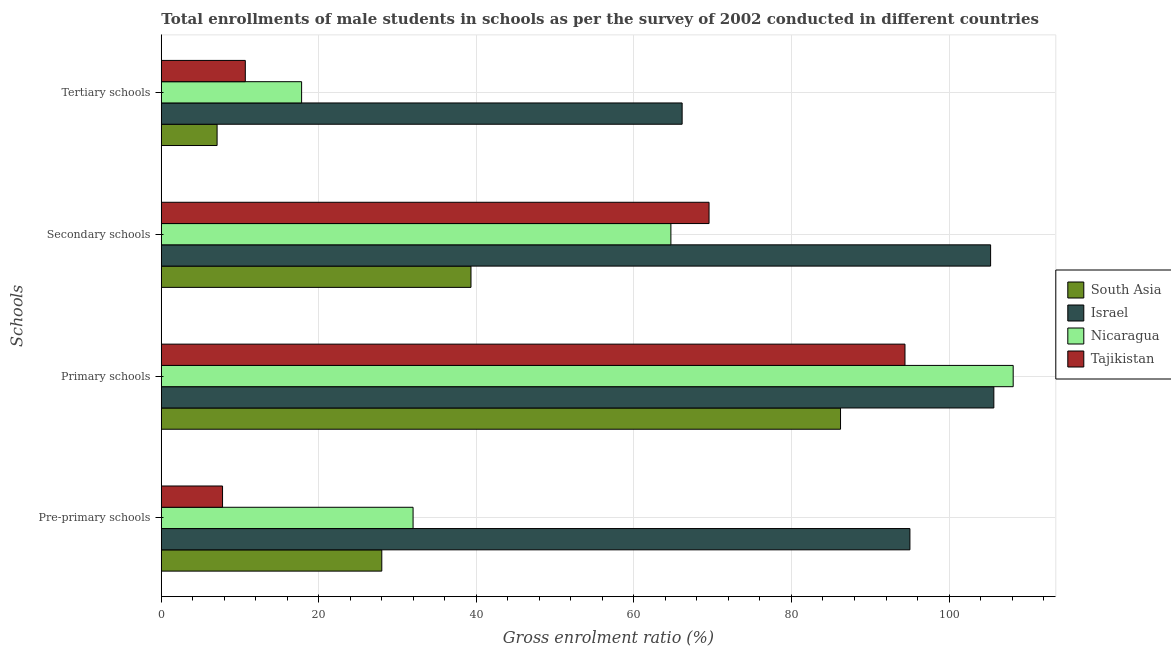How many bars are there on the 4th tick from the top?
Provide a succinct answer. 4. What is the label of the 2nd group of bars from the top?
Keep it short and to the point. Secondary schools. What is the gross enrolment ratio(male) in pre-primary schools in Israel?
Offer a terse response. 95.04. Across all countries, what is the maximum gross enrolment ratio(male) in primary schools?
Your response must be concise. 108.15. Across all countries, what is the minimum gross enrolment ratio(male) in pre-primary schools?
Your answer should be very brief. 7.77. What is the total gross enrolment ratio(male) in secondary schools in the graph?
Provide a succinct answer. 278.82. What is the difference between the gross enrolment ratio(male) in primary schools in South Asia and that in Israel?
Keep it short and to the point. -19.46. What is the difference between the gross enrolment ratio(male) in tertiary schools in Tajikistan and the gross enrolment ratio(male) in primary schools in Israel?
Offer a terse response. -95.03. What is the average gross enrolment ratio(male) in tertiary schools per country?
Make the answer very short. 25.42. What is the difference between the gross enrolment ratio(male) in primary schools and gross enrolment ratio(male) in secondary schools in Nicaragua?
Offer a very short reply. 43.46. In how many countries, is the gross enrolment ratio(male) in tertiary schools greater than 40 %?
Your answer should be compact. 1. What is the ratio of the gross enrolment ratio(male) in secondary schools in Tajikistan to that in South Asia?
Provide a short and direct response. 1.77. Is the difference between the gross enrolment ratio(male) in primary schools in Nicaragua and Israel greater than the difference between the gross enrolment ratio(male) in pre-primary schools in Nicaragua and Israel?
Provide a succinct answer. Yes. What is the difference between the highest and the second highest gross enrolment ratio(male) in primary schools?
Your answer should be very brief. 2.46. What is the difference between the highest and the lowest gross enrolment ratio(male) in primary schools?
Your response must be concise. 21.92. Is it the case that in every country, the sum of the gross enrolment ratio(male) in primary schools and gross enrolment ratio(male) in tertiary schools is greater than the sum of gross enrolment ratio(male) in pre-primary schools and gross enrolment ratio(male) in secondary schools?
Ensure brevity in your answer.  No. What does the 4th bar from the top in Pre-primary schools represents?
Give a very brief answer. South Asia. What does the 4th bar from the bottom in Secondary schools represents?
Keep it short and to the point. Tajikistan. Are all the bars in the graph horizontal?
Provide a succinct answer. Yes. How many countries are there in the graph?
Give a very brief answer. 4. What is the difference between two consecutive major ticks on the X-axis?
Ensure brevity in your answer.  20. Are the values on the major ticks of X-axis written in scientific E-notation?
Ensure brevity in your answer.  No. Does the graph contain any zero values?
Keep it short and to the point. No. Does the graph contain grids?
Your answer should be very brief. Yes. Where does the legend appear in the graph?
Provide a short and direct response. Center right. What is the title of the graph?
Ensure brevity in your answer.  Total enrollments of male students in schools as per the survey of 2002 conducted in different countries. What is the label or title of the Y-axis?
Provide a succinct answer. Schools. What is the Gross enrolment ratio (%) of South Asia in Pre-primary schools?
Your answer should be compact. 27.99. What is the Gross enrolment ratio (%) in Israel in Pre-primary schools?
Provide a succinct answer. 95.04. What is the Gross enrolment ratio (%) in Nicaragua in Pre-primary schools?
Offer a very short reply. 31.96. What is the Gross enrolment ratio (%) in Tajikistan in Pre-primary schools?
Give a very brief answer. 7.77. What is the Gross enrolment ratio (%) in South Asia in Primary schools?
Make the answer very short. 86.23. What is the Gross enrolment ratio (%) in Israel in Primary schools?
Keep it short and to the point. 105.69. What is the Gross enrolment ratio (%) in Nicaragua in Primary schools?
Provide a succinct answer. 108.15. What is the Gross enrolment ratio (%) of Tajikistan in Primary schools?
Your answer should be compact. 94.41. What is the Gross enrolment ratio (%) of South Asia in Secondary schools?
Give a very brief answer. 39.31. What is the Gross enrolment ratio (%) of Israel in Secondary schools?
Give a very brief answer. 105.28. What is the Gross enrolment ratio (%) of Nicaragua in Secondary schools?
Provide a short and direct response. 64.69. What is the Gross enrolment ratio (%) of Tajikistan in Secondary schools?
Provide a short and direct response. 69.54. What is the Gross enrolment ratio (%) in South Asia in Tertiary schools?
Make the answer very short. 7.08. What is the Gross enrolment ratio (%) of Israel in Tertiary schools?
Offer a very short reply. 66.12. What is the Gross enrolment ratio (%) in Nicaragua in Tertiary schools?
Give a very brief answer. 17.81. What is the Gross enrolment ratio (%) in Tajikistan in Tertiary schools?
Your response must be concise. 10.66. Across all Schools, what is the maximum Gross enrolment ratio (%) of South Asia?
Your answer should be compact. 86.23. Across all Schools, what is the maximum Gross enrolment ratio (%) of Israel?
Offer a very short reply. 105.69. Across all Schools, what is the maximum Gross enrolment ratio (%) of Nicaragua?
Offer a terse response. 108.15. Across all Schools, what is the maximum Gross enrolment ratio (%) in Tajikistan?
Provide a short and direct response. 94.41. Across all Schools, what is the minimum Gross enrolment ratio (%) of South Asia?
Offer a terse response. 7.08. Across all Schools, what is the minimum Gross enrolment ratio (%) of Israel?
Your answer should be compact. 66.12. Across all Schools, what is the minimum Gross enrolment ratio (%) in Nicaragua?
Offer a very short reply. 17.81. Across all Schools, what is the minimum Gross enrolment ratio (%) of Tajikistan?
Make the answer very short. 7.77. What is the total Gross enrolment ratio (%) in South Asia in the graph?
Offer a terse response. 160.61. What is the total Gross enrolment ratio (%) in Israel in the graph?
Offer a terse response. 372.13. What is the total Gross enrolment ratio (%) in Nicaragua in the graph?
Your answer should be very brief. 222.61. What is the total Gross enrolment ratio (%) of Tajikistan in the graph?
Provide a succinct answer. 182.38. What is the difference between the Gross enrolment ratio (%) in South Asia in Pre-primary schools and that in Primary schools?
Provide a short and direct response. -58.24. What is the difference between the Gross enrolment ratio (%) in Israel in Pre-primary schools and that in Primary schools?
Provide a short and direct response. -10.65. What is the difference between the Gross enrolment ratio (%) of Nicaragua in Pre-primary schools and that in Primary schools?
Ensure brevity in your answer.  -76.19. What is the difference between the Gross enrolment ratio (%) in Tajikistan in Pre-primary schools and that in Primary schools?
Your response must be concise. -86.64. What is the difference between the Gross enrolment ratio (%) in South Asia in Pre-primary schools and that in Secondary schools?
Give a very brief answer. -11.32. What is the difference between the Gross enrolment ratio (%) of Israel in Pre-primary schools and that in Secondary schools?
Provide a succinct answer. -10.24. What is the difference between the Gross enrolment ratio (%) of Nicaragua in Pre-primary schools and that in Secondary schools?
Offer a very short reply. -32.73. What is the difference between the Gross enrolment ratio (%) in Tajikistan in Pre-primary schools and that in Secondary schools?
Your answer should be compact. -61.76. What is the difference between the Gross enrolment ratio (%) of South Asia in Pre-primary schools and that in Tertiary schools?
Make the answer very short. 20.91. What is the difference between the Gross enrolment ratio (%) in Israel in Pre-primary schools and that in Tertiary schools?
Your answer should be compact. 28.92. What is the difference between the Gross enrolment ratio (%) in Nicaragua in Pre-primary schools and that in Tertiary schools?
Your answer should be compact. 14.15. What is the difference between the Gross enrolment ratio (%) in Tajikistan in Pre-primary schools and that in Tertiary schools?
Your answer should be compact. -2.89. What is the difference between the Gross enrolment ratio (%) in South Asia in Primary schools and that in Secondary schools?
Provide a succinct answer. 46.91. What is the difference between the Gross enrolment ratio (%) of Israel in Primary schools and that in Secondary schools?
Your response must be concise. 0.41. What is the difference between the Gross enrolment ratio (%) in Nicaragua in Primary schools and that in Secondary schools?
Offer a very short reply. 43.46. What is the difference between the Gross enrolment ratio (%) in Tajikistan in Primary schools and that in Secondary schools?
Your response must be concise. 24.87. What is the difference between the Gross enrolment ratio (%) of South Asia in Primary schools and that in Tertiary schools?
Your answer should be very brief. 79.15. What is the difference between the Gross enrolment ratio (%) in Israel in Primary schools and that in Tertiary schools?
Offer a terse response. 39.57. What is the difference between the Gross enrolment ratio (%) of Nicaragua in Primary schools and that in Tertiary schools?
Your response must be concise. 90.34. What is the difference between the Gross enrolment ratio (%) in Tajikistan in Primary schools and that in Tertiary schools?
Keep it short and to the point. 83.75. What is the difference between the Gross enrolment ratio (%) in South Asia in Secondary schools and that in Tertiary schools?
Give a very brief answer. 32.23. What is the difference between the Gross enrolment ratio (%) in Israel in Secondary schools and that in Tertiary schools?
Give a very brief answer. 39.16. What is the difference between the Gross enrolment ratio (%) of Nicaragua in Secondary schools and that in Tertiary schools?
Ensure brevity in your answer.  46.88. What is the difference between the Gross enrolment ratio (%) in Tajikistan in Secondary schools and that in Tertiary schools?
Provide a succinct answer. 58.87. What is the difference between the Gross enrolment ratio (%) in South Asia in Pre-primary schools and the Gross enrolment ratio (%) in Israel in Primary schools?
Give a very brief answer. -77.7. What is the difference between the Gross enrolment ratio (%) of South Asia in Pre-primary schools and the Gross enrolment ratio (%) of Nicaragua in Primary schools?
Offer a very short reply. -80.16. What is the difference between the Gross enrolment ratio (%) in South Asia in Pre-primary schools and the Gross enrolment ratio (%) in Tajikistan in Primary schools?
Ensure brevity in your answer.  -66.42. What is the difference between the Gross enrolment ratio (%) of Israel in Pre-primary schools and the Gross enrolment ratio (%) of Nicaragua in Primary schools?
Offer a terse response. -13.11. What is the difference between the Gross enrolment ratio (%) in Israel in Pre-primary schools and the Gross enrolment ratio (%) in Tajikistan in Primary schools?
Your response must be concise. 0.63. What is the difference between the Gross enrolment ratio (%) in Nicaragua in Pre-primary schools and the Gross enrolment ratio (%) in Tajikistan in Primary schools?
Your answer should be compact. -62.45. What is the difference between the Gross enrolment ratio (%) of South Asia in Pre-primary schools and the Gross enrolment ratio (%) of Israel in Secondary schools?
Provide a short and direct response. -77.29. What is the difference between the Gross enrolment ratio (%) in South Asia in Pre-primary schools and the Gross enrolment ratio (%) in Nicaragua in Secondary schools?
Provide a short and direct response. -36.7. What is the difference between the Gross enrolment ratio (%) in South Asia in Pre-primary schools and the Gross enrolment ratio (%) in Tajikistan in Secondary schools?
Provide a short and direct response. -41.55. What is the difference between the Gross enrolment ratio (%) in Israel in Pre-primary schools and the Gross enrolment ratio (%) in Nicaragua in Secondary schools?
Provide a short and direct response. 30.35. What is the difference between the Gross enrolment ratio (%) of Israel in Pre-primary schools and the Gross enrolment ratio (%) of Tajikistan in Secondary schools?
Give a very brief answer. 25.5. What is the difference between the Gross enrolment ratio (%) of Nicaragua in Pre-primary schools and the Gross enrolment ratio (%) of Tajikistan in Secondary schools?
Make the answer very short. -37.57. What is the difference between the Gross enrolment ratio (%) of South Asia in Pre-primary schools and the Gross enrolment ratio (%) of Israel in Tertiary schools?
Provide a succinct answer. -38.13. What is the difference between the Gross enrolment ratio (%) of South Asia in Pre-primary schools and the Gross enrolment ratio (%) of Nicaragua in Tertiary schools?
Offer a very short reply. 10.18. What is the difference between the Gross enrolment ratio (%) in South Asia in Pre-primary schools and the Gross enrolment ratio (%) in Tajikistan in Tertiary schools?
Offer a terse response. 17.33. What is the difference between the Gross enrolment ratio (%) in Israel in Pre-primary schools and the Gross enrolment ratio (%) in Nicaragua in Tertiary schools?
Provide a short and direct response. 77.23. What is the difference between the Gross enrolment ratio (%) in Israel in Pre-primary schools and the Gross enrolment ratio (%) in Tajikistan in Tertiary schools?
Give a very brief answer. 84.37. What is the difference between the Gross enrolment ratio (%) of Nicaragua in Pre-primary schools and the Gross enrolment ratio (%) of Tajikistan in Tertiary schools?
Provide a short and direct response. 21.3. What is the difference between the Gross enrolment ratio (%) in South Asia in Primary schools and the Gross enrolment ratio (%) in Israel in Secondary schools?
Provide a short and direct response. -19.05. What is the difference between the Gross enrolment ratio (%) of South Asia in Primary schools and the Gross enrolment ratio (%) of Nicaragua in Secondary schools?
Offer a terse response. 21.53. What is the difference between the Gross enrolment ratio (%) of South Asia in Primary schools and the Gross enrolment ratio (%) of Tajikistan in Secondary schools?
Give a very brief answer. 16.69. What is the difference between the Gross enrolment ratio (%) of Israel in Primary schools and the Gross enrolment ratio (%) of Nicaragua in Secondary schools?
Your answer should be very brief. 41. What is the difference between the Gross enrolment ratio (%) in Israel in Primary schools and the Gross enrolment ratio (%) in Tajikistan in Secondary schools?
Ensure brevity in your answer.  36.15. What is the difference between the Gross enrolment ratio (%) in Nicaragua in Primary schools and the Gross enrolment ratio (%) in Tajikistan in Secondary schools?
Give a very brief answer. 38.61. What is the difference between the Gross enrolment ratio (%) in South Asia in Primary schools and the Gross enrolment ratio (%) in Israel in Tertiary schools?
Your answer should be compact. 20.11. What is the difference between the Gross enrolment ratio (%) in South Asia in Primary schools and the Gross enrolment ratio (%) in Nicaragua in Tertiary schools?
Make the answer very short. 68.42. What is the difference between the Gross enrolment ratio (%) in South Asia in Primary schools and the Gross enrolment ratio (%) in Tajikistan in Tertiary schools?
Offer a very short reply. 75.56. What is the difference between the Gross enrolment ratio (%) of Israel in Primary schools and the Gross enrolment ratio (%) of Nicaragua in Tertiary schools?
Your response must be concise. 87.88. What is the difference between the Gross enrolment ratio (%) of Israel in Primary schools and the Gross enrolment ratio (%) of Tajikistan in Tertiary schools?
Your answer should be very brief. 95.03. What is the difference between the Gross enrolment ratio (%) in Nicaragua in Primary schools and the Gross enrolment ratio (%) in Tajikistan in Tertiary schools?
Your response must be concise. 97.49. What is the difference between the Gross enrolment ratio (%) of South Asia in Secondary schools and the Gross enrolment ratio (%) of Israel in Tertiary schools?
Your answer should be compact. -26.81. What is the difference between the Gross enrolment ratio (%) in South Asia in Secondary schools and the Gross enrolment ratio (%) in Nicaragua in Tertiary schools?
Your response must be concise. 21.5. What is the difference between the Gross enrolment ratio (%) in South Asia in Secondary schools and the Gross enrolment ratio (%) in Tajikistan in Tertiary schools?
Keep it short and to the point. 28.65. What is the difference between the Gross enrolment ratio (%) of Israel in Secondary schools and the Gross enrolment ratio (%) of Nicaragua in Tertiary schools?
Offer a very short reply. 87.47. What is the difference between the Gross enrolment ratio (%) of Israel in Secondary schools and the Gross enrolment ratio (%) of Tajikistan in Tertiary schools?
Provide a succinct answer. 94.62. What is the difference between the Gross enrolment ratio (%) in Nicaragua in Secondary schools and the Gross enrolment ratio (%) in Tajikistan in Tertiary schools?
Your response must be concise. 54.03. What is the average Gross enrolment ratio (%) of South Asia per Schools?
Offer a terse response. 40.15. What is the average Gross enrolment ratio (%) in Israel per Schools?
Give a very brief answer. 93.03. What is the average Gross enrolment ratio (%) of Nicaragua per Schools?
Give a very brief answer. 55.65. What is the average Gross enrolment ratio (%) in Tajikistan per Schools?
Keep it short and to the point. 45.6. What is the difference between the Gross enrolment ratio (%) of South Asia and Gross enrolment ratio (%) of Israel in Pre-primary schools?
Keep it short and to the point. -67.05. What is the difference between the Gross enrolment ratio (%) of South Asia and Gross enrolment ratio (%) of Nicaragua in Pre-primary schools?
Ensure brevity in your answer.  -3.97. What is the difference between the Gross enrolment ratio (%) in South Asia and Gross enrolment ratio (%) in Tajikistan in Pre-primary schools?
Offer a terse response. 20.22. What is the difference between the Gross enrolment ratio (%) in Israel and Gross enrolment ratio (%) in Nicaragua in Pre-primary schools?
Your answer should be very brief. 63.08. What is the difference between the Gross enrolment ratio (%) in Israel and Gross enrolment ratio (%) in Tajikistan in Pre-primary schools?
Provide a short and direct response. 87.26. What is the difference between the Gross enrolment ratio (%) of Nicaragua and Gross enrolment ratio (%) of Tajikistan in Pre-primary schools?
Provide a succinct answer. 24.19. What is the difference between the Gross enrolment ratio (%) of South Asia and Gross enrolment ratio (%) of Israel in Primary schools?
Make the answer very short. -19.46. What is the difference between the Gross enrolment ratio (%) of South Asia and Gross enrolment ratio (%) of Nicaragua in Primary schools?
Your answer should be very brief. -21.92. What is the difference between the Gross enrolment ratio (%) in South Asia and Gross enrolment ratio (%) in Tajikistan in Primary schools?
Your answer should be very brief. -8.18. What is the difference between the Gross enrolment ratio (%) in Israel and Gross enrolment ratio (%) in Nicaragua in Primary schools?
Offer a terse response. -2.46. What is the difference between the Gross enrolment ratio (%) in Israel and Gross enrolment ratio (%) in Tajikistan in Primary schools?
Ensure brevity in your answer.  11.28. What is the difference between the Gross enrolment ratio (%) in Nicaragua and Gross enrolment ratio (%) in Tajikistan in Primary schools?
Keep it short and to the point. 13.74. What is the difference between the Gross enrolment ratio (%) in South Asia and Gross enrolment ratio (%) in Israel in Secondary schools?
Ensure brevity in your answer.  -65.97. What is the difference between the Gross enrolment ratio (%) of South Asia and Gross enrolment ratio (%) of Nicaragua in Secondary schools?
Provide a succinct answer. -25.38. What is the difference between the Gross enrolment ratio (%) in South Asia and Gross enrolment ratio (%) in Tajikistan in Secondary schools?
Keep it short and to the point. -30.22. What is the difference between the Gross enrolment ratio (%) in Israel and Gross enrolment ratio (%) in Nicaragua in Secondary schools?
Offer a terse response. 40.59. What is the difference between the Gross enrolment ratio (%) of Israel and Gross enrolment ratio (%) of Tajikistan in Secondary schools?
Keep it short and to the point. 35.74. What is the difference between the Gross enrolment ratio (%) in Nicaragua and Gross enrolment ratio (%) in Tajikistan in Secondary schools?
Make the answer very short. -4.84. What is the difference between the Gross enrolment ratio (%) in South Asia and Gross enrolment ratio (%) in Israel in Tertiary schools?
Keep it short and to the point. -59.04. What is the difference between the Gross enrolment ratio (%) of South Asia and Gross enrolment ratio (%) of Nicaragua in Tertiary schools?
Your answer should be compact. -10.73. What is the difference between the Gross enrolment ratio (%) of South Asia and Gross enrolment ratio (%) of Tajikistan in Tertiary schools?
Provide a succinct answer. -3.58. What is the difference between the Gross enrolment ratio (%) of Israel and Gross enrolment ratio (%) of Nicaragua in Tertiary schools?
Keep it short and to the point. 48.31. What is the difference between the Gross enrolment ratio (%) in Israel and Gross enrolment ratio (%) in Tajikistan in Tertiary schools?
Give a very brief answer. 55.46. What is the difference between the Gross enrolment ratio (%) in Nicaragua and Gross enrolment ratio (%) in Tajikistan in Tertiary schools?
Your answer should be very brief. 7.15. What is the ratio of the Gross enrolment ratio (%) of South Asia in Pre-primary schools to that in Primary schools?
Your answer should be compact. 0.32. What is the ratio of the Gross enrolment ratio (%) in Israel in Pre-primary schools to that in Primary schools?
Make the answer very short. 0.9. What is the ratio of the Gross enrolment ratio (%) of Nicaragua in Pre-primary schools to that in Primary schools?
Provide a succinct answer. 0.3. What is the ratio of the Gross enrolment ratio (%) of Tajikistan in Pre-primary schools to that in Primary schools?
Your answer should be compact. 0.08. What is the ratio of the Gross enrolment ratio (%) of South Asia in Pre-primary schools to that in Secondary schools?
Offer a terse response. 0.71. What is the ratio of the Gross enrolment ratio (%) in Israel in Pre-primary schools to that in Secondary schools?
Ensure brevity in your answer.  0.9. What is the ratio of the Gross enrolment ratio (%) in Nicaragua in Pre-primary schools to that in Secondary schools?
Your answer should be very brief. 0.49. What is the ratio of the Gross enrolment ratio (%) of Tajikistan in Pre-primary schools to that in Secondary schools?
Your answer should be compact. 0.11. What is the ratio of the Gross enrolment ratio (%) in South Asia in Pre-primary schools to that in Tertiary schools?
Ensure brevity in your answer.  3.95. What is the ratio of the Gross enrolment ratio (%) in Israel in Pre-primary schools to that in Tertiary schools?
Give a very brief answer. 1.44. What is the ratio of the Gross enrolment ratio (%) in Nicaragua in Pre-primary schools to that in Tertiary schools?
Offer a very short reply. 1.79. What is the ratio of the Gross enrolment ratio (%) in Tajikistan in Pre-primary schools to that in Tertiary schools?
Your response must be concise. 0.73. What is the ratio of the Gross enrolment ratio (%) in South Asia in Primary schools to that in Secondary schools?
Make the answer very short. 2.19. What is the ratio of the Gross enrolment ratio (%) in Nicaragua in Primary schools to that in Secondary schools?
Keep it short and to the point. 1.67. What is the ratio of the Gross enrolment ratio (%) of Tajikistan in Primary schools to that in Secondary schools?
Provide a succinct answer. 1.36. What is the ratio of the Gross enrolment ratio (%) of South Asia in Primary schools to that in Tertiary schools?
Provide a succinct answer. 12.18. What is the ratio of the Gross enrolment ratio (%) of Israel in Primary schools to that in Tertiary schools?
Your answer should be very brief. 1.6. What is the ratio of the Gross enrolment ratio (%) in Nicaragua in Primary schools to that in Tertiary schools?
Provide a succinct answer. 6.07. What is the ratio of the Gross enrolment ratio (%) of Tajikistan in Primary schools to that in Tertiary schools?
Offer a very short reply. 8.85. What is the ratio of the Gross enrolment ratio (%) in South Asia in Secondary schools to that in Tertiary schools?
Make the answer very short. 5.55. What is the ratio of the Gross enrolment ratio (%) in Israel in Secondary schools to that in Tertiary schools?
Provide a short and direct response. 1.59. What is the ratio of the Gross enrolment ratio (%) of Nicaragua in Secondary schools to that in Tertiary schools?
Your answer should be compact. 3.63. What is the ratio of the Gross enrolment ratio (%) in Tajikistan in Secondary schools to that in Tertiary schools?
Provide a short and direct response. 6.52. What is the difference between the highest and the second highest Gross enrolment ratio (%) of South Asia?
Offer a very short reply. 46.91. What is the difference between the highest and the second highest Gross enrolment ratio (%) in Israel?
Provide a short and direct response. 0.41. What is the difference between the highest and the second highest Gross enrolment ratio (%) in Nicaragua?
Your response must be concise. 43.46. What is the difference between the highest and the second highest Gross enrolment ratio (%) in Tajikistan?
Your answer should be very brief. 24.87. What is the difference between the highest and the lowest Gross enrolment ratio (%) in South Asia?
Your response must be concise. 79.15. What is the difference between the highest and the lowest Gross enrolment ratio (%) in Israel?
Make the answer very short. 39.57. What is the difference between the highest and the lowest Gross enrolment ratio (%) of Nicaragua?
Your answer should be very brief. 90.34. What is the difference between the highest and the lowest Gross enrolment ratio (%) of Tajikistan?
Make the answer very short. 86.64. 